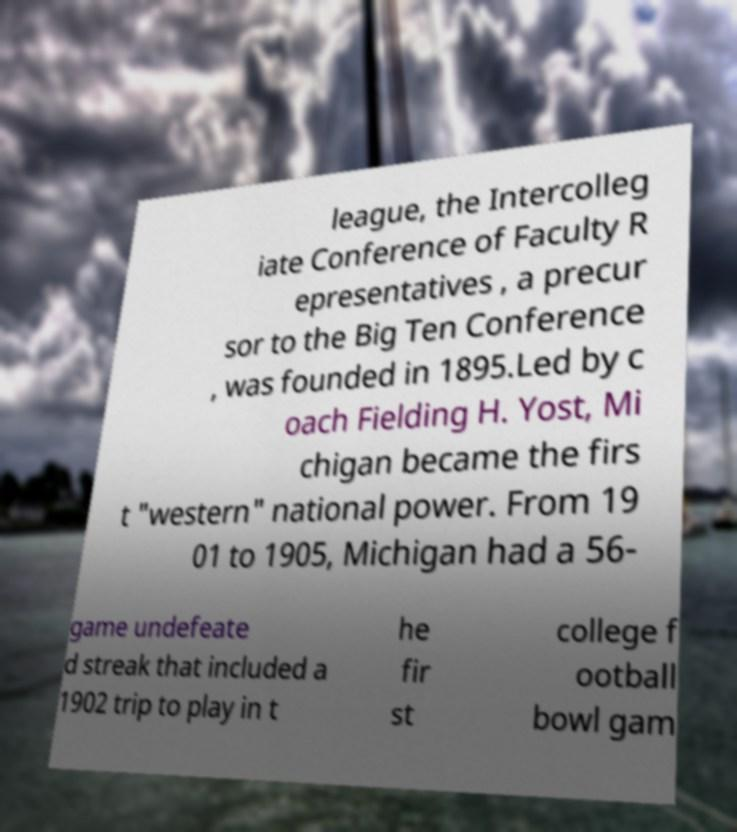I need the written content from this picture converted into text. Can you do that? league, the Intercolleg iate Conference of Faculty R epresentatives , a precur sor to the Big Ten Conference , was founded in 1895.Led by c oach Fielding H. Yost, Mi chigan became the firs t "western" national power. From 19 01 to 1905, Michigan had a 56- game undefeate d streak that included a 1902 trip to play in t he fir st college f ootball bowl gam 